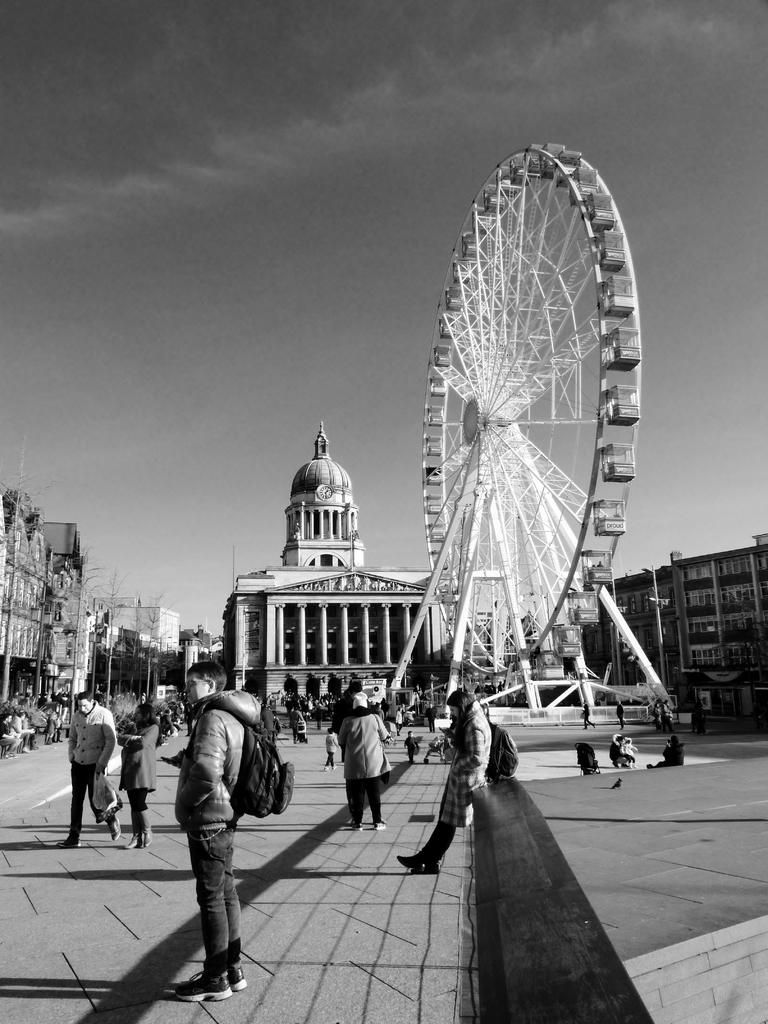What are the people in the image doing? The people in the image are standing on the road. Can you describe any specific items the people are carrying? Two persons are wearing backpacks. What is the large structure in the image? There is a giant wheel in the image. What can be seen in the background of the image? There are buildings and the sky visible in the background. What type of punishment is being administered to the people in the image? There is no punishment being administered to the people in the image; they are simply standing on the road. Can you describe the crib that is visible in the image? There is no crib present in the image. 